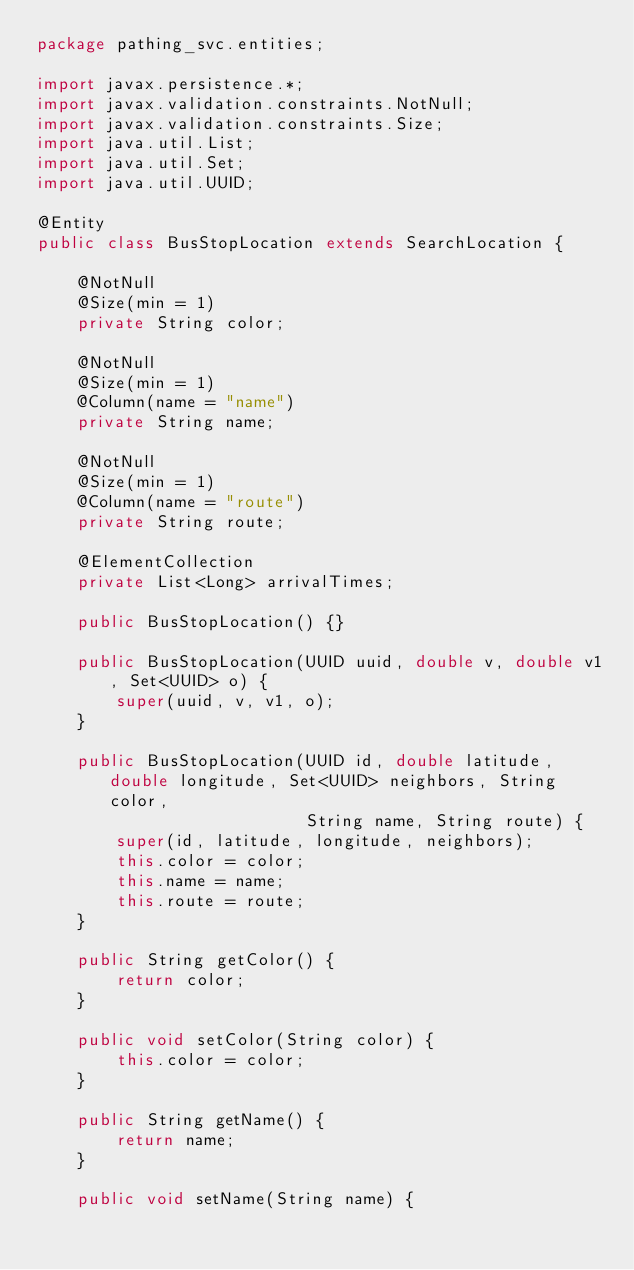Convert code to text. <code><loc_0><loc_0><loc_500><loc_500><_Java_>package pathing_svc.entities;

import javax.persistence.*;
import javax.validation.constraints.NotNull;
import javax.validation.constraints.Size;
import java.util.List;
import java.util.Set;
import java.util.UUID;

@Entity
public class BusStopLocation extends SearchLocation {

    @NotNull
    @Size(min = 1)
    private String color;

    @NotNull
    @Size(min = 1)
    @Column(name = "name")
    private String name;

    @NotNull
    @Size(min = 1)
    @Column(name = "route")
    private String route;

    @ElementCollection
    private List<Long> arrivalTimes;

    public BusStopLocation() {}

    public BusStopLocation(UUID uuid, double v, double v1, Set<UUID> o) {
        super(uuid, v, v1, o);
    }

    public BusStopLocation(UUID id, double latitude, double longitude, Set<UUID> neighbors, String color,
                           String name, String route) {
        super(id, latitude, longitude, neighbors);
        this.color = color;
        this.name = name;
        this.route = route;
    }

    public String getColor() {
        return color;
    }

    public void setColor(String color) {
        this.color = color;
    }

    public String getName() {
        return name;
    }

    public void setName(String name) {</code> 